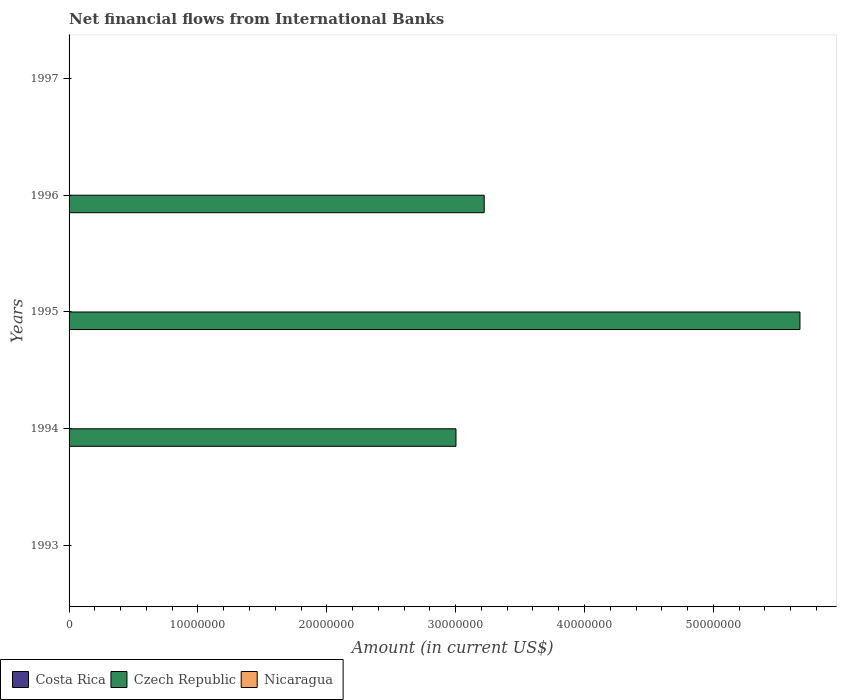How many bars are there on the 3rd tick from the bottom?
Provide a succinct answer. 1. What is the label of the 2nd group of bars from the top?
Your response must be concise. 1996. Across all years, what is the maximum net financial aid flows in Czech Republic?
Keep it short and to the point. 5.67e+07. What is the total net financial aid flows in Nicaragua in the graph?
Your answer should be compact. 0. What is the average net financial aid flows in Czech Republic per year?
Give a very brief answer. 2.38e+07. What is the difference between the highest and the second highest net financial aid flows in Czech Republic?
Provide a succinct answer. 2.45e+07. What is the difference between the highest and the lowest net financial aid flows in Czech Republic?
Offer a terse response. 5.67e+07. How many years are there in the graph?
Ensure brevity in your answer.  5. Are the values on the major ticks of X-axis written in scientific E-notation?
Offer a terse response. No. How are the legend labels stacked?
Ensure brevity in your answer.  Horizontal. What is the title of the graph?
Your answer should be compact. Net financial flows from International Banks. What is the label or title of the X-axis?
Give a very brief answer. Amount (in current US$). What is the Amount (in current US$) in Costa Rica in 1993?
Your answer should be very brief. 0. What is the Amount (in current US$) in Czech Republic in 1993?
Provide a succinct answer. 0. What is the Amount (in current US$) in Nicaragua in 1993?
Provide a succinct answer. 0. What is the Amount (in current US$) in Costa Rica in 1994?
Give a very brief answer. 0. What is the Amount (in current US$) in Czech Republic in 1994?
Give a very brief answer. 3.00e+07. What is the Amount (in current US$) of Nicaragua in 1994?
Ensure brevity in your answer.  0. What is the Amount (in current US$) in Costa Rica in 1995?
Your answer should be compact. 0. What is the Amount (in current US$) of Czech Republic in 1995?
Provide a succinct answer. 5.67e+07. What is the Amount (in current US$) in Nicaragua in 1995?
Provide a short and direct response. 0. What is the Amount (in current US$) in Czech Republic in 1996?
Your answer should be very brief. 3.22e+07. What is the Amount (in current US$) of Nicaragua in 1996?
Your response must be concise. 0. What is the Amount (in current US$) of Costa Rica in 1997?
Give a very brief answer. 0. What is the Amount (in current US$) of Czech Republic in 1997?
Keep it short and to the point. 0. What is the Amount (in current US$) in Nicaragua in 1997?
Your response must be concise. 0. Across all years, what is the maximum Amount (in current US$) in Czech Republic?
Provide a short and direct response. 5.67e+07. What is the total Amount (in current US$) in Czech Republic in the graph?
Offer a very short reply. 1.19e+08. What is the total Amount (in current US$) in Nicaragua in the graph?
Ensure brevity in your answer.  0. What is the difference between the Amount (in current US$) in Czech Republic in 1994 and that in 1995?
Offer a terse response. -2.67e+07. What is the difference between the Amount (in current US$) in Czech Republic in 1994 and that in 1996?
Ensure brevity in your answer.  -2.19e+06. What is the difference between the Amount (in current US$) in Czech Republic in 1995 and that in 1996?
Offer a terse response. 2.45e+07. What is the average Amount (in current US$) in Czech Republic per year?
Provide a short and direct response. 2.38e+07. What is the average Amount (in current US$) in Nicaragua per year?
Your answer should be very brief. 0. What is the ratio of the Amount (in current US$) of Czech Republic in 1994 to that in 1995?
Ensure brevity in your answer.  0.53. What is the ratio of the Amount (in current US$) in Czech Republic in 1994 to that in 1996?
Provide a short and direct response. 0.93. What is the ratio of the Amount (in current US$) in Czech Republic in 1995 to that in 1996?
Your answer should be compact. 1.76. What is the difference between the highest and the second highest Amount (in current US$) in Czech Republic?
Offer a very short reply. 2.45e+07. What is the difference between the highest and the lowest Amount (in current US$) in Czech Republic?
Provide a short and direct response. 5.67e+07. 